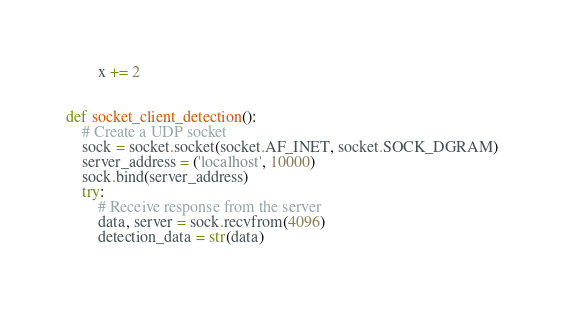Convert code to text. <code><loc_0><loc_0><loc_500><loc_500><_Python_>        x += 2


def socket_client_detection():
    # Create a UDP socket
    sock = socket.socket(socket.AF_INET, socket.SOCK_DGRAM)
    server_address = ('localhost', 10000)
    sock.bind(server_address)
    try:
        # Receive response from the server
        data, server = sock.recvfrom(4096)
        detection_data = str(data)</code> 